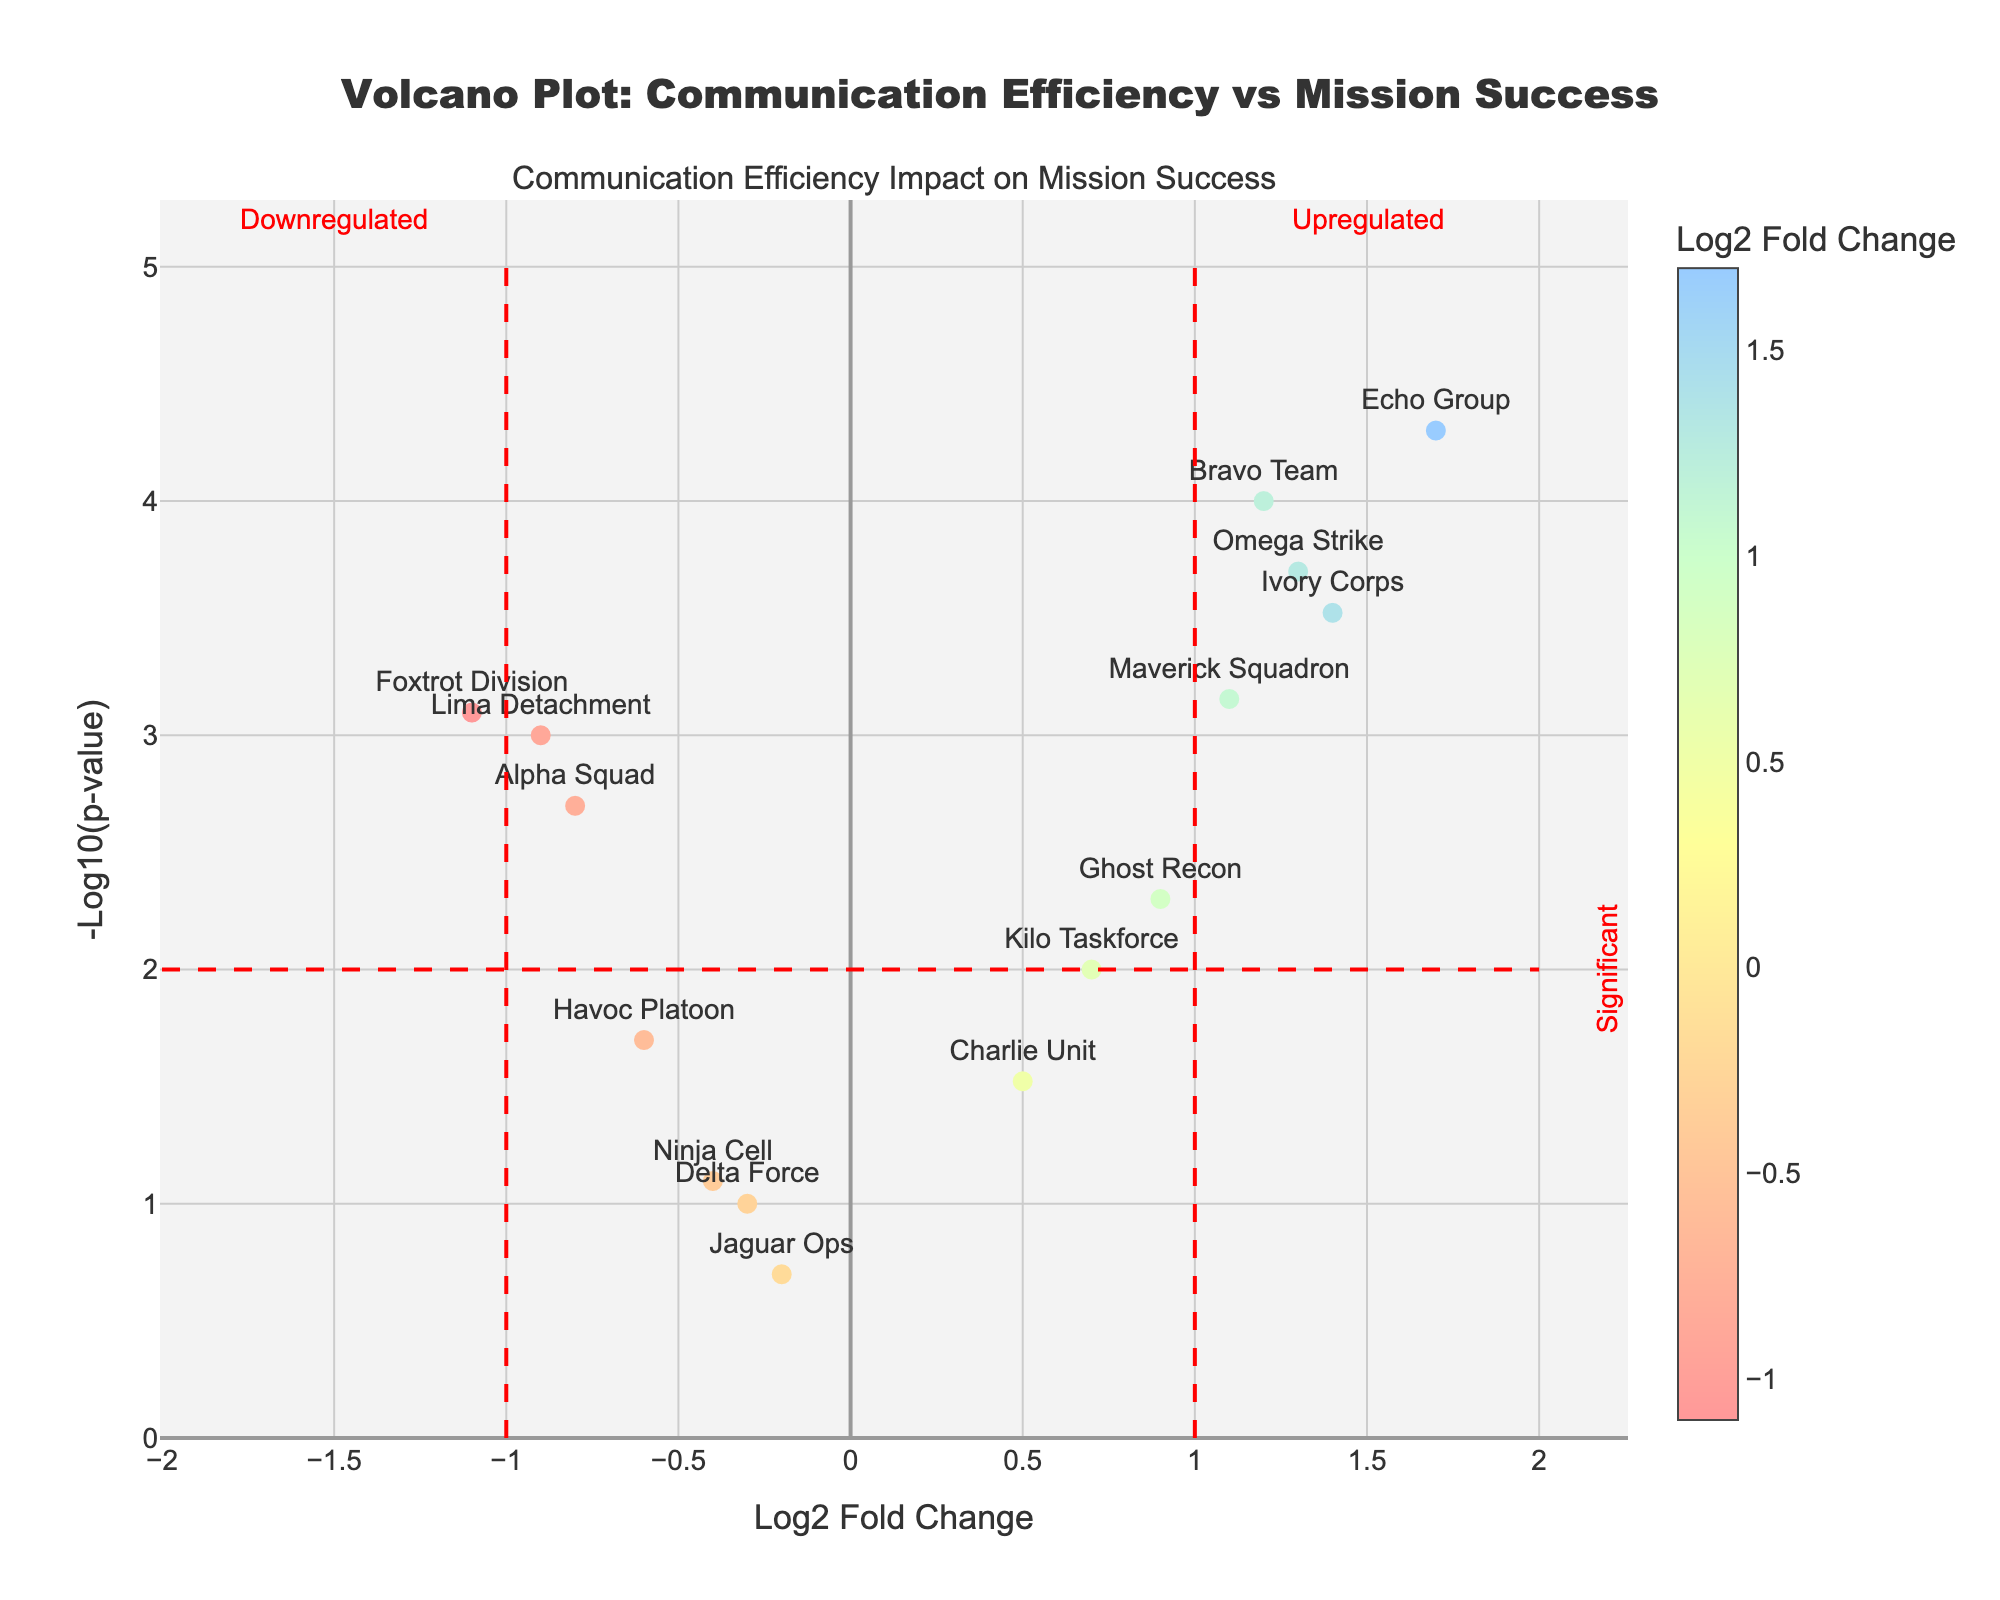what is the title of the plot? The title is displayed at the top center of the graph. It reads 'Volcano Plot: Communication Efficiency vs Mission Success'
Answer: Volcano Plot: Communication Efficiency vs Mission Success how is the y-axis labeled? The y-axis label is located on the left side of the plot. It reads '-Log10(p-value)'
Answer: -Log10(p-value) which team has the highest log2 fold change? The highest log2 fold change can be identified by looking at the point farthest to the right on the x-axis. 'Echo Group' has the most positive log2 fold change of 1.7
Answer: Echo Group which team has the lowest log2 fold change? The lowest log2 fold change can be identified by looking at the point farthest to the left on the x-axis. 'Foxtrot Division' has the most negative log2 fold change of -1.1
Answer: Foxtrot Division what is the significance threshold for the y-axis and which teams pass it? The significance threshold on the y-axis is shown by a horizontal red dashed line at y=2. Teams whose points are above this line are considered significant. These teams include 'Alpha Squad', 'Bravo Team', 'Echo Group', 'Foxtrot Division', 'Ivory Corps', 'Lima Detachment', 'Maverick Squadron', and 'Omega Strike'
Answer: Alpha Squad, Bravo Team, Echo Group, Foxtrot Division, Ivory Corps, Lima Detachment, Maverick Squadron, Omega Strike which teams have a downregulated log2 fold change and are significant? Downregulated log2 fold changes are those to the left of x=-1 and significant points are below the red dashed threshold at y=2. 'Foxtrot Division' and 'Lima Detachment' fit these criteria.
Answer: Foxtrot Division, Lima Detachment how is the color of the markers determined? The color of the markers is based on the log2 fold change values. The scale uses colors that change from one end of the spectrum to the other to indicate low to high values.
Answer: By the log2 fold change values which teams fall into the upregulated and significant category? Upregulated log2 fold changes are those to the right of x=1 and significant points are above the horizontal red dashed line at y=2. 'Bravo Team', 'Echo Group', 'Ivory Corps', 'Maverick Squadron', and 'Omega Strike' fall into this category.
Answer: Bravo Team, Echo Group, Ivory Corps, Maverick Squadron, Omega Strike what does the presence of red dashed lines at x=-1 and x=1 signify? The vertical red dashed lines at x=-1 and x=1 indicate thresholds for downregulated (left of -1) and upregulated (right of 1) log2 fold changes. Values outside these boundaries are considered biologically significant for downregulation and upregulation.
Answer: Thresholds for downregulated and upregulated how does the communication efficiency correlate with mission success for Ghost Recon? For 'Ghost Recon', the log2 fold change is 0.9, indicating a positive but not strongly upregulated communication efficiency. The p-value reflects a more moderate significance at around 2.30 when converted to -log10(p-value). This suggests communication efficiency has a notable but not exceptional impact on their mission success.
Answer: Positive correlation with moderate significance 